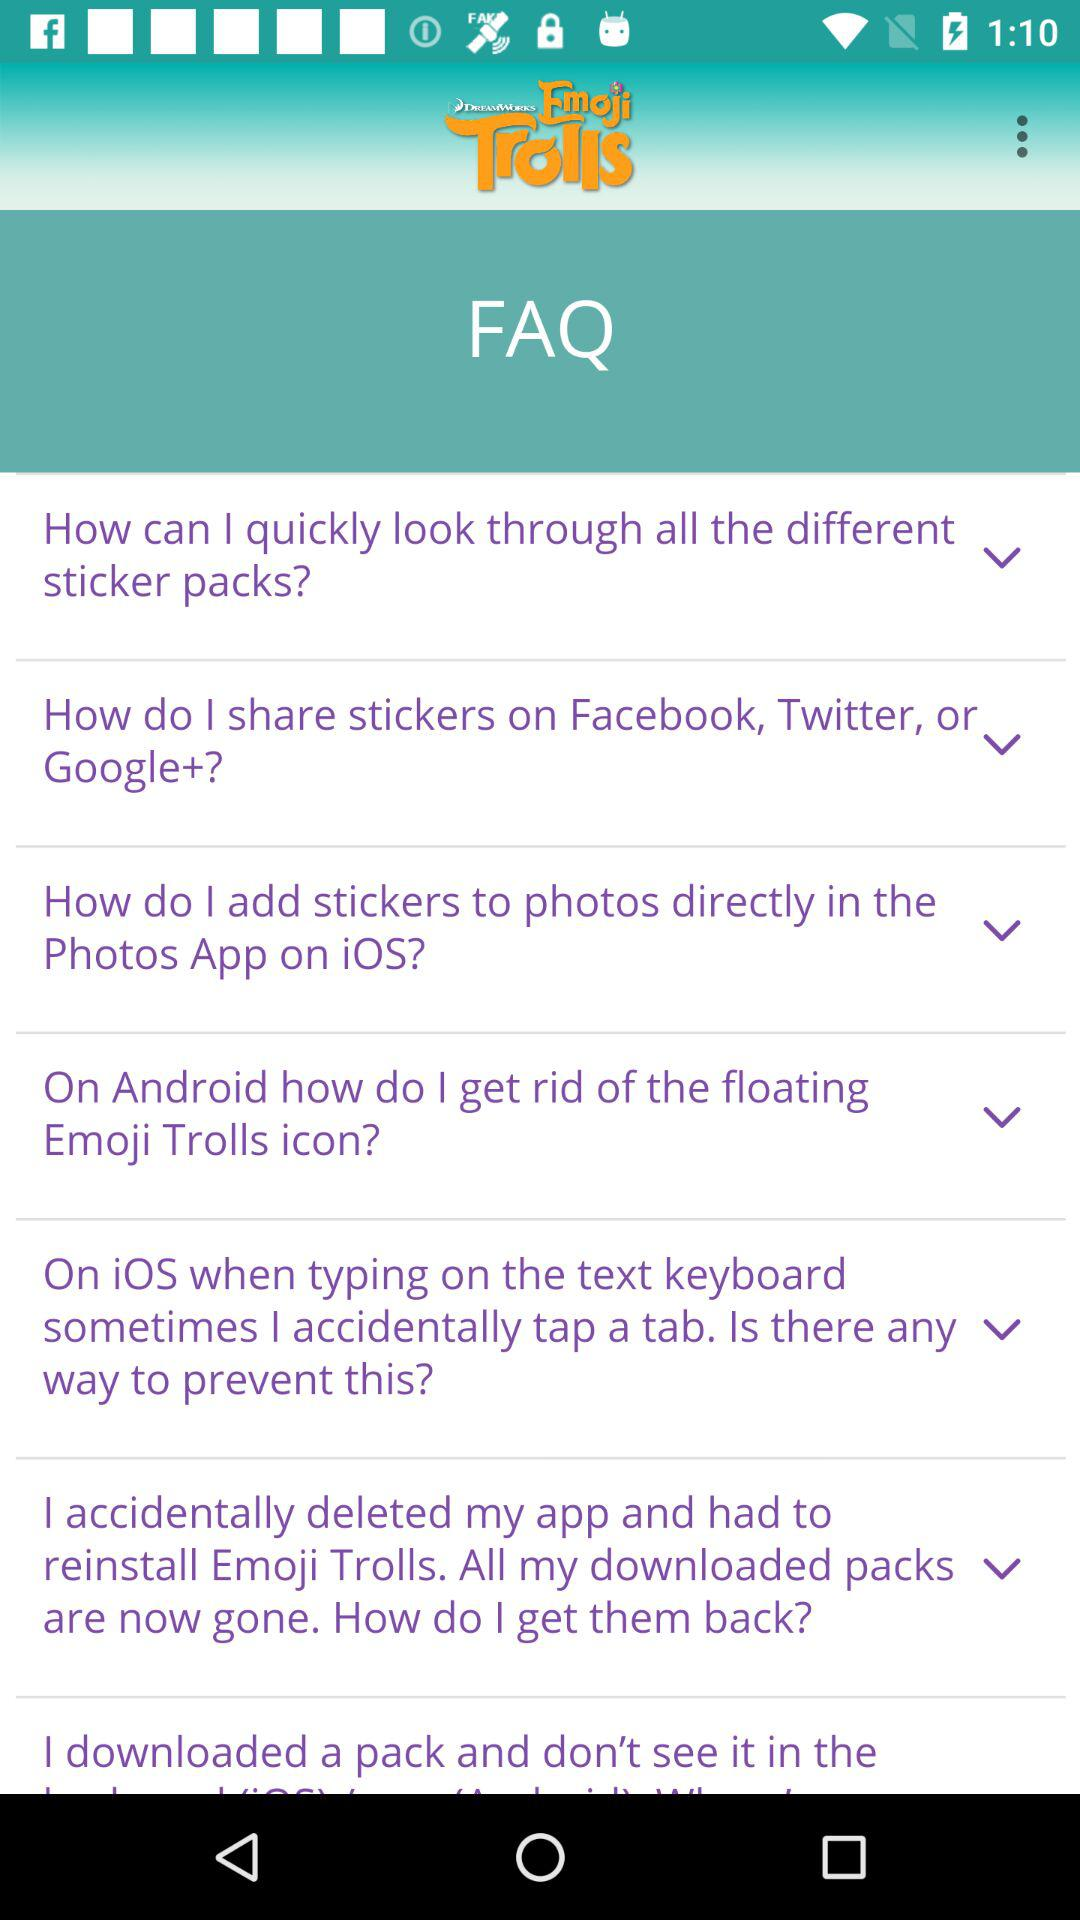What is the app name? The app name is "Emoji Trolls". 